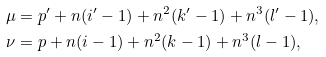Convert formula to latex. <formula><loc_0><loc_0><loc_500><loc_500>\mu & = p ^ { \prime } + n ( i ^ { \prime } - 1 ) + n ^ { 2 } ( k ^ { \prime } - 1 ) + n ^ { 3 } ( l ^ { \prime } - 1 ) , \\ \nu & = p + n ( i - 1 ) + n ^ { 2 } ( k - 1 ) + n ^ { 3 } ( l - 1 ) ,</formula> 